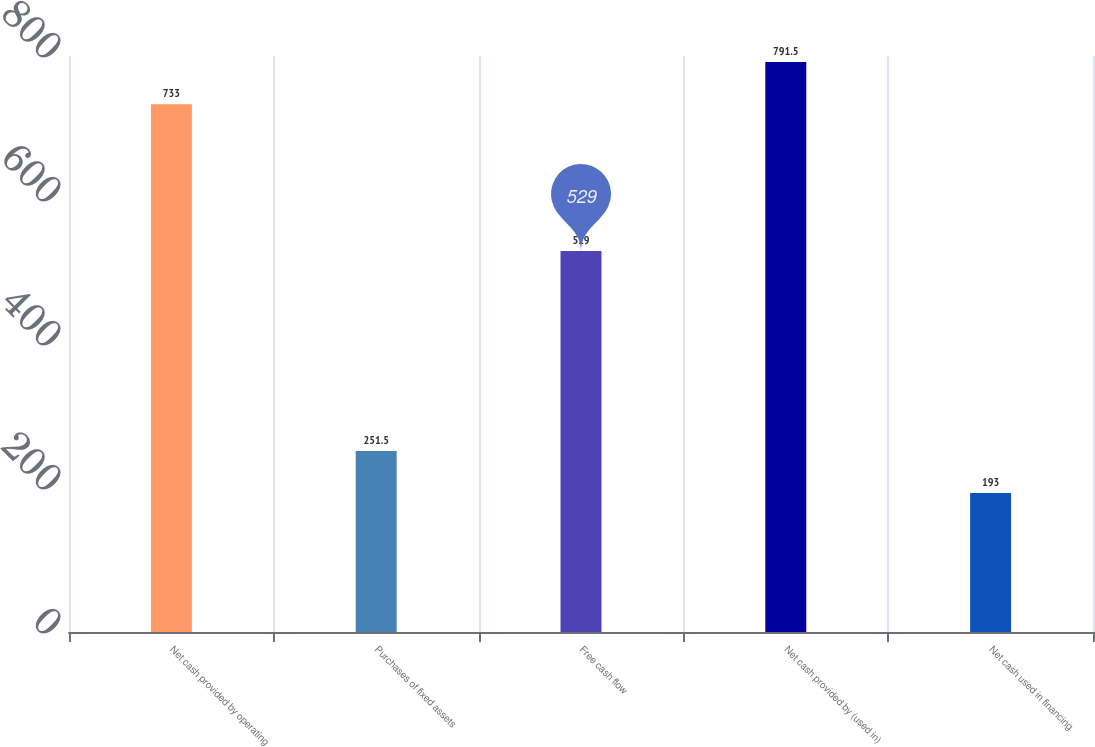<chart> <loc_0><loc_0><loc_500><loc_500><bar_chart><fcel>Net cash provided by operating<fcel>Purchases of fixed assets<fcel>Free cash flow<fcel>Net cash provided by (used in)<fcel>Net cash used in financing<nl><fcel>733<fcel>251.5<fcel>529<fcel>791.5<fcel>193<nl></chart> 